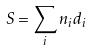<formula> <loc_0><loc_0><loc_500><loc_500>S = \sum _ { i } n _ { i } d _ { i }</formula> 